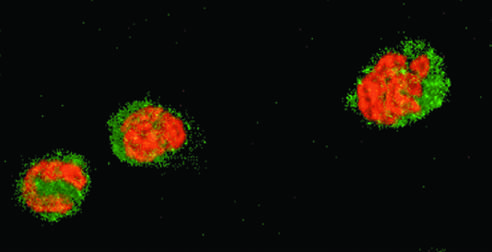did the areas of white chalky deposits stain red and cytoplasm green?
Answer the question using a single word or phrase. No 